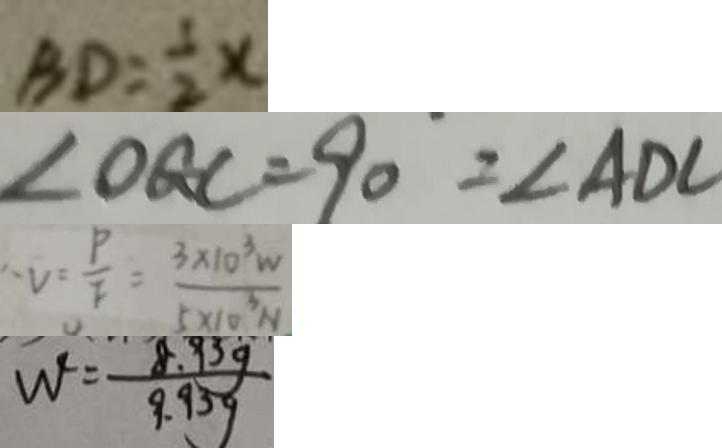<formula> <loc_0><loc_0><loc_500><loc_500>B D = \frac { 1 } { 2 } x 
 \angle O G C = 9 0 ^ { \circ } = \angle A D C 
 V = \frac { P } { F } = \frac { 3 \times 1 0 ^ { 3 } W } { 5 \times 1 0 ^ { 3 } N } 
 W ^ { \prime } = \frac { 8 . 9 3 g } { 9 . 9 3 g }</formula> 